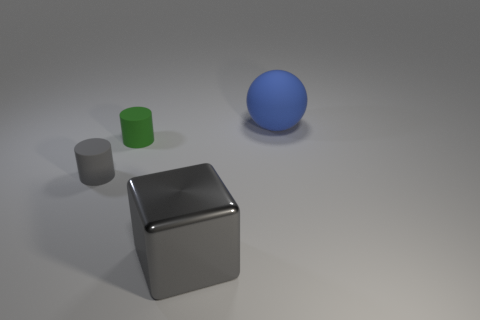Are there any other things that have the same shape as the large gray metallic thing? The large gray metallic object appears to be a cube. Looking at the shapes presented in the image, we do have another object that shares this cube shape, which is the smaller gray cube. The other objects include a cylinder and a sphere, which are different shapes. 